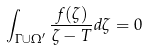Convert formula to latex. <formula><loc_0><loc_0><loc_500><loc_500>\int _ { \Gamma \cup \Omega ^ { \prime } } \frac { f ( \zeta ) } { \zeta - T } d \zeta = 0</formula> 